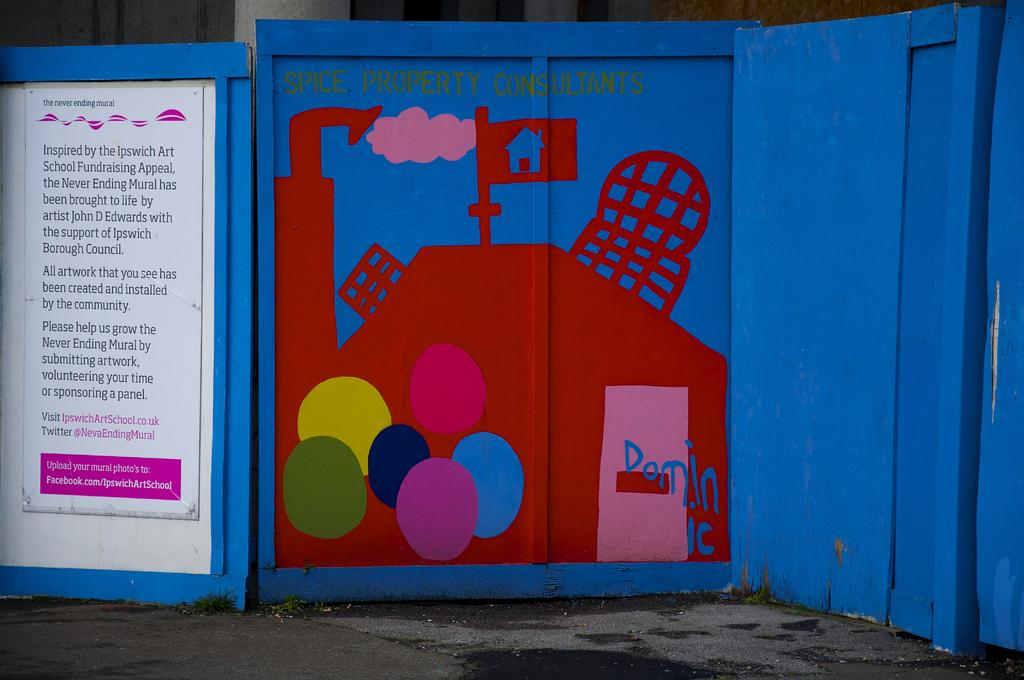<image>
Write a terse but informative summary of the picture. A picture in red on blue with Spice Property Consultations written on it. 